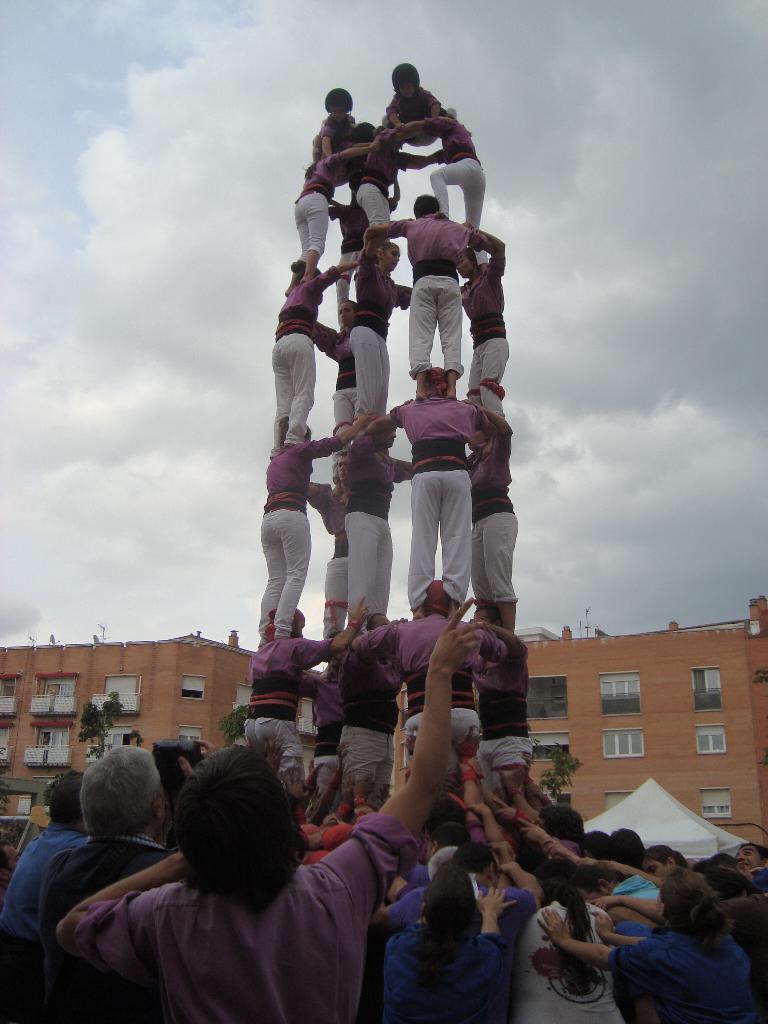Can you describe this image briefly? In this image I can see number of persons are standing on the ground and few persons wearing pink, black and white colored dresses are standing on each other. In the background I can see few buildings which are brown in color, few windows of the building and the sky. 